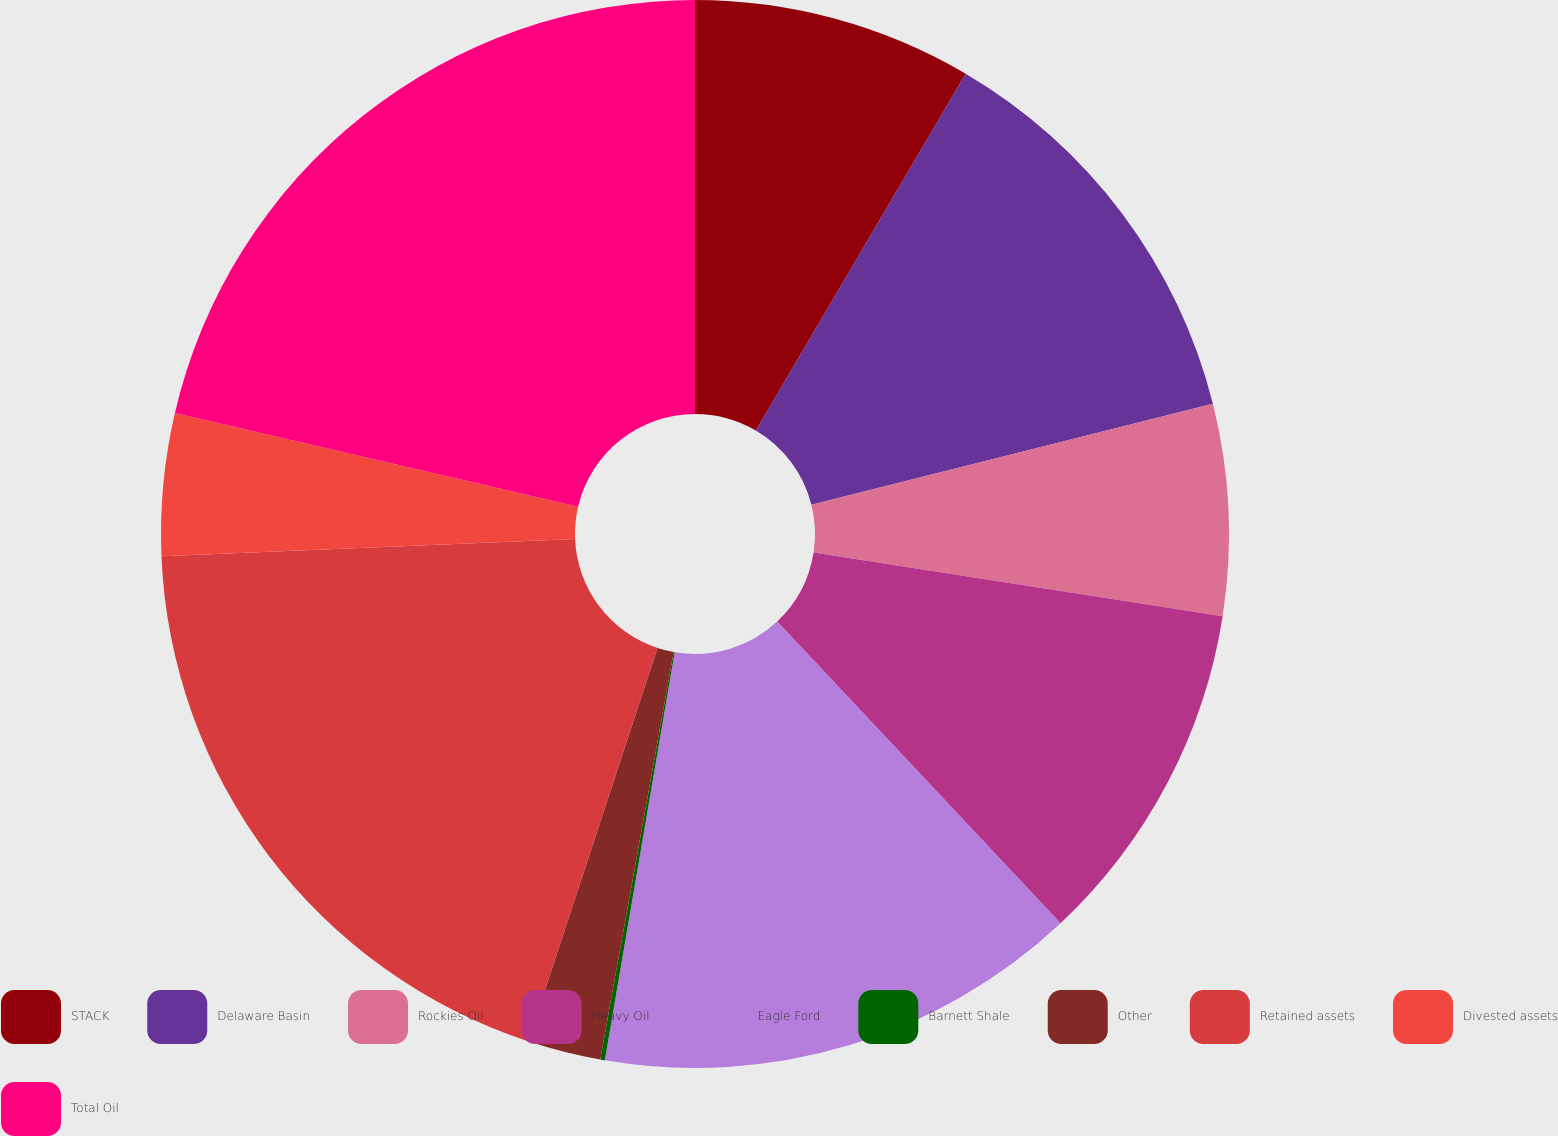Convert chart. <chart><loc_0><loc_0><loc_500><loc_500><pie_chart><fcel>STACK<fcel>Delaware Basin<fcel>Rockies Oil<fcel>Heavy Oil<fcel>Eagle Ford<fcel>Barnett Shale<fcel>Other<fcel>Retained assets<fcel>Divested assets<fcel>Total Oil<nl><fcel>8.46%<fcel>12.62%<fcel>6.38%<fcel>10.54%<fcel>14.7%<fcel>0.14%<fcel>2.22%<fcel>19.28%<fcel>4.3%<fcel>21.36%<nl></chart> 